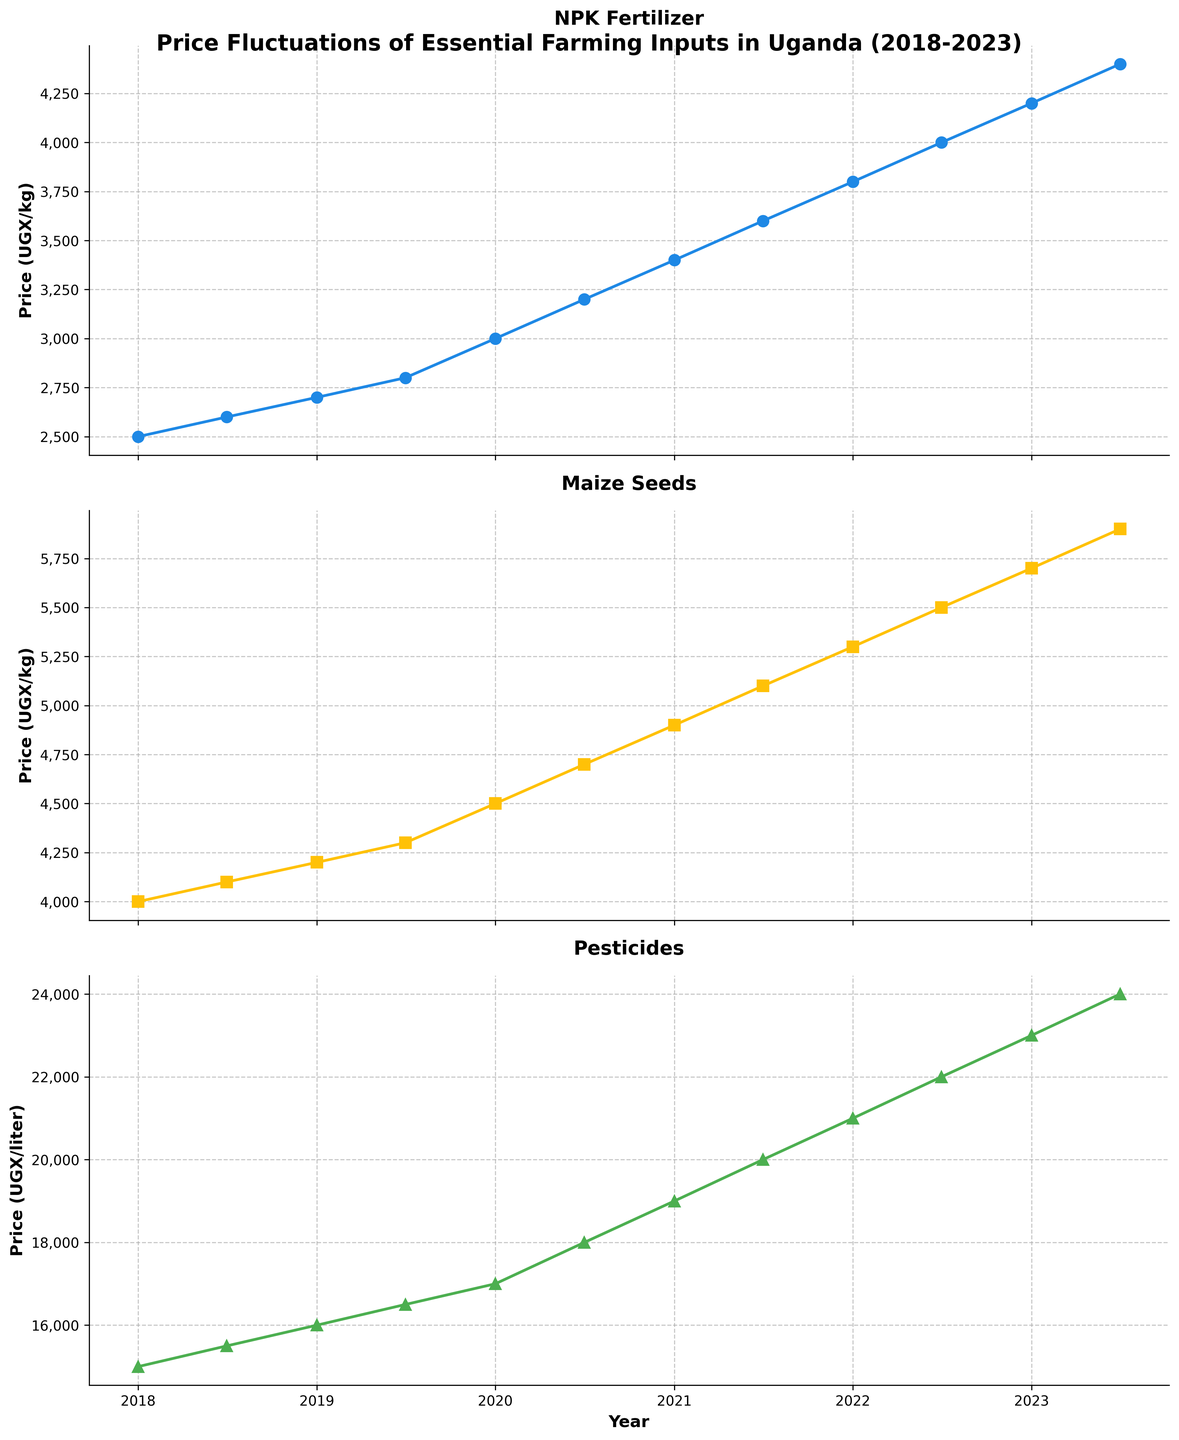How many subplots are there in the figure, and what are they titled? There are three subplots in the figure. Their titles are "NPK Fertilizer", "Maize Seeds", and "Pesticides".
Answer: Three; NPK Fertilizer, Maize Seeds, Pesticides What is the price of NPK Fertilizer in January 2023? The price of NPK Fertilizer can be found by looking at the value corresponding to January 2023 on the NPK Fertilizer subplot. It is 4200 UGX/kg.
Answer: 4200 UGX/kg Which farming input has the highest price recorded in the given period? To find the highest price recorded, look at the peak point on all three subplots. The highest recorded price is for Pesticides, reaching 24000 UGX/liter in July 2023.
Answer: Pesticides What is the price difference of Maize Seeds between January 2018 and July 2023? The price of Maize Seeds in January 2018 is 4000 UGX/kg, and in July 2023, it is 5900 UGX/kg. The price difference is 5900 - 4000 = 1900 UGX/kg.
Answer: 1900 UGX/kg Which input shows the most significant increase in price over the five years? Compare the price changes from January 2018 to July 2023 for each input: NPK Fertilizer from 2500 to 4400 (1900 increase), Maize Seeds from 4000 to 5900 (1900 increase), and Pesticides from 15000 to 24000 (9000 increase). Pesticides have the largest increase.
Answer: Pesticides What is the average price of NPK Fertilizer over all recorded periods? Sum the prices of NPK Fertilizer at each data point and divide by the number of data points: (2500 + 2600 + 2700 + 2800 + 3000 + 3200 + 3400 + 3600 + 3800 + 4000 + 4200 + 4400) / 12 = 3325 UGX/kg.
Answer: 3325 UGX/kg In which year did Pesticides exceed 20000 UGX/liter for the first time? By analyzing the Pesticides plot, we see that the price first exceeds 20000 UGX/liter in January 2021.
Answer: 2021 Did the price of any farming input decrease at any point between two consecutive periods? Check each subplot for any downward trends between two consecutive data points. All lines show a continuous upward trend with no decreases.
Answer: No 